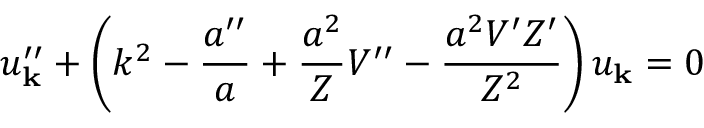<formula> <loc_0><loc_0><loc_500><loc_500>u _ { k } ^ { \prime \prime } + \left ( k ^ { 2 } - \frac { a ^ { \prime \prime } } { a } + \frac { a ^ { 2 } } { Z } V ^ { \prime \prime } - \frac { a ^ { 2 } V ^ { \prime } Z ^ { \prime } } { Z ^ { 2 } } \right ) u _ { k } = 0</formula> 